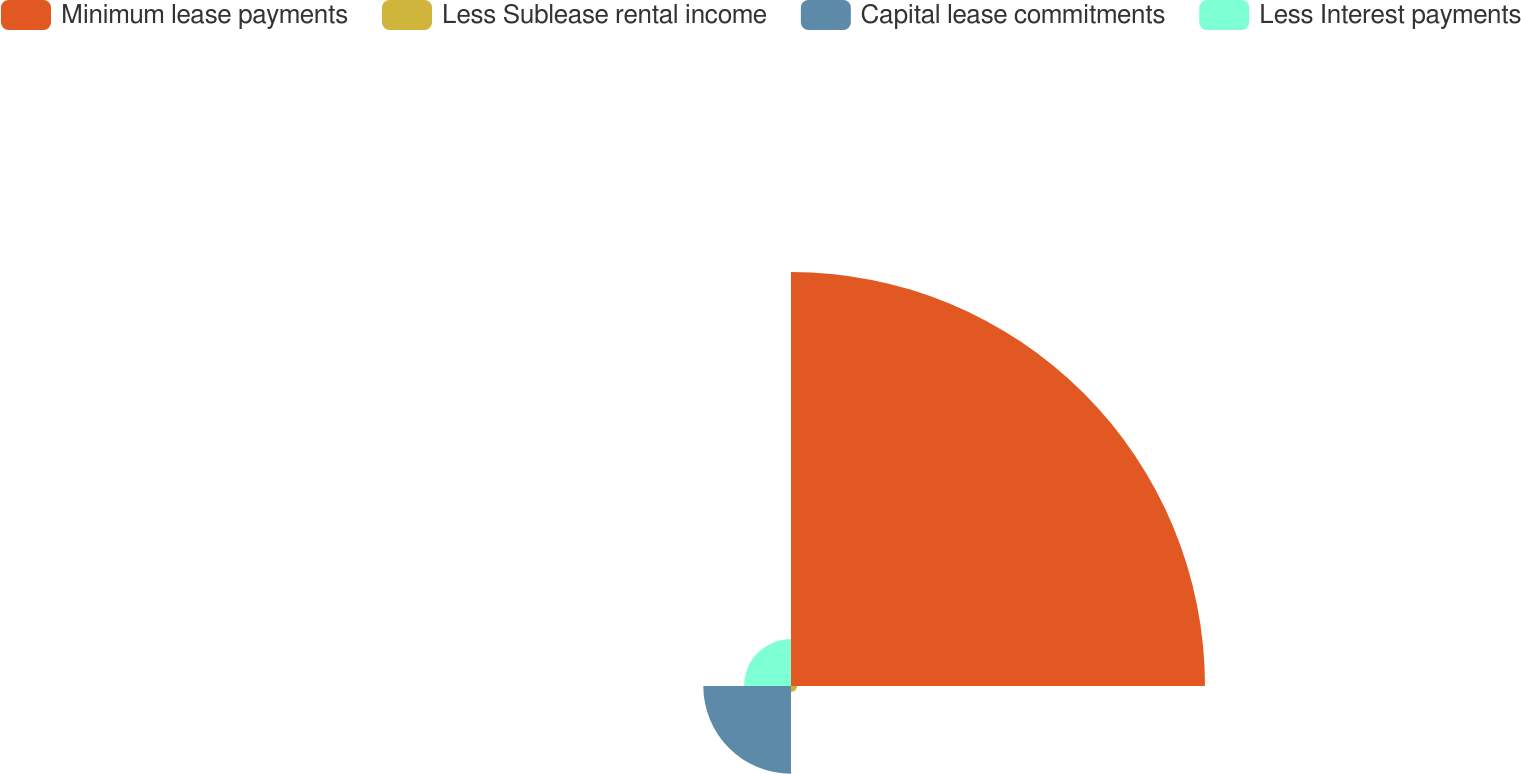Convert chart. <chart><loc_0><loc_0><loc_500><loc_500><pie_chart><fcel>Minimum lease payments<fcel>Less Sublease rental income<fcel>Capital lease commitments<fcel>Less Interest payments<nl><fcel>74.61%<fcel>1.11%<fcel>15.81%<fcel>8.46%<nl></chart> 